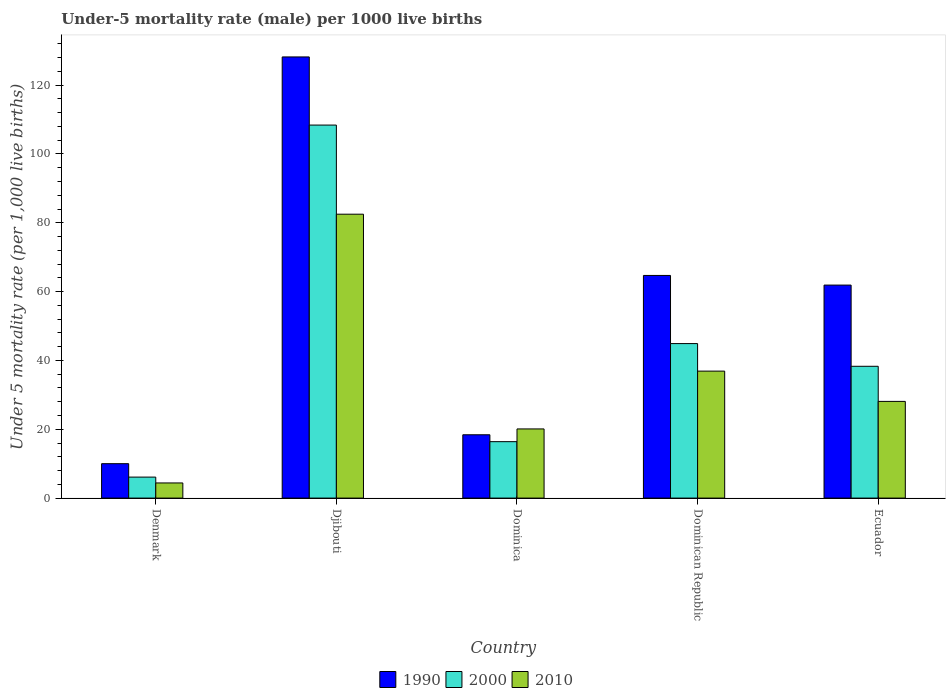How many groups of bars are there?
Ensure brevity in your answer.  5. How many bars are there on the 1st tick from the left?
Give a very brief answer. 3. How many bars are there on the 2nd tick from the right?
Offer a terse response. 3. In how many cases, is the number of bars for a given country not equal to the number of legend labels?
Offer a very short reply. 0. Across all countries, what is the maximum under-five mortality rate in 1990?
Keep it short and to the point. 128.2. In which country was the under-five mortality rate in 2010 maximum?
Provide a succinct answer. Djibouti. In which country was the under-five mortality rate in 1990 minimum?
Your answer should be compact. Denmark. What is the total under-five mortality rate in 2000 in the graph?
Provide a succinct answer. 214.1. What is the difference between the under-five mortality rate in 2010 in Denmark and that in Ecuador?
Keep it short and to the point. -23.7. What is the difference between the under-five mortality rate in 1990 in Dominican Republic and the under-five mortality rate in 2010 in Denmark?
Give a very brief answer. 60.3. What is the average under-five mortality rate in 2000 per country?
Your response must be concise. 42.82. What is the difference between the under-five mortality rate of/in 2000 and under-five mortality rate of/in 1990 in Dominican Republic?
Give a very brief answer. -19.8. In how many countries, is the under-five mortality rate in 2010 greater than 108?
Your answer should be compact. 0. What is the ratio of the under-five mortality rate in 1990 in Dominican Republic to that in Ecuador?
Ensure brevity in your answer.  1.05. Is the under-five mortality rate in 2000 in Denmark less than that in Dominica?
Your response must be concise. Yes. What is the difference between the highest and the second highest under-five mortality rate in 2010?
Provide a succinct answer. 45.6. What is the difference between the highest and the lowest under-five mortality rate in 2000?
Your answer should be very brief. 102.3. What does the 1st bar from the right in Dominican Republic represents?
Your response must be concise. 2010. Is it the case that in every country, the sum of the under-five mortality rate in 1990 and under-five mortality rate in 2010 is greater than the under-five mortality rate in 2000?
Offer a terse response. Yes. How many bars are there?
Your answer should be compact. 15. Are all the bars in the graph horizontal?
Provide a short and direct response. No. Are the values on the major ticks of Y-axis written in scientific E-notation?
Your response must be concise. No. Does the graph contain any zero values?
Provide a short and direct response. No. Where does the legend appear in the graph?
Your answer should be very brief. Bottom center. How many legend labels are there?
Your answer should be very brief. 3. How are the legend labels stacked?
Your answer should be compact. Horizontal. What is the title of the graph?
Ensure brevity in your answer.  Under-5 mortality rate (male) per 1000 live births. What is the label or title of the Y-axis?
Your answer should be compact. Under 5 mortality rate (per 1,0 live births). What is the Under 5 mortality rate (per 1,000 live births) in 1990 in Denmark?
Keep it short and to the point. 10. What is the Under 5 mortality rate (per 1,000 live births) of 1990 in Djibouti?
Give a very brief answer. 128.2. What is the Under 5 mortality rate (per 1,000 live births) in 2000 in Djibouti?
Your response must be concise. 108.4. What is the Under 5 mortality rate (per 1,000 live births) of 2010 in Djibouti?
Give a very brief answer. 82.5. What is the Under 5 mortality rate (per 1,000 live births) of 2010 in Dominica?
Ensure brevity in your answer.  20.1. What is the Under 5 mortality rate (per 1,000 live births) in 1990 in Dominican Republic?
Offer a terse response. 64.7. What is the Under 5 mortality rate (per 1,000 live births) in 2000 in Dominican Republic?
Keep it short and to the point. 44.9. What is the Under 5 mortality rate (per 1,000 live births) in 2010 in Dominican Republic?
Your answer should be compact. 36.9. What is the Under 5 mortality rate (per 1,000 live births) in 1990 in Ecuador?
Provide a short and direct response. 61.9. What is the Under 5 mortality rate (per 1,000 live births) in 2000 in Ecuador?
Keep it short and to the point. 38.3. What is the Under 5 mortality rate (per 1,000 live births) in 2010 in Ecuador?
Offer a terse response. 28.1. Across all countries, what is the maximum Under 5 mortality rate (per 1,000 live births) in 1990?
Provide a succinct answer. 128.2. Across all countries, what is the maximum Under 5 mortality rate (per 1,000 live births) in 2000?
Your response must be concise. 108.4. Across all countries, what is the maximum Under 5 mortality rate (per 1,000 live births) in 2010?
Offer a terse response. 82.5. Across all countries, what is the minimum Under 5 mortality rate (per 1,000 live births) in 2000?
Your answer should be compact. 6.1. What is the total Under 5 mortality rate (per 1,000 live births) in 1990 in the graph?
Offer a very short reply. 283.2. What is the total Under 5 mortality rate (per 1,000 live births) of 2000 in the graph?
Your answer should be very brief. 214.1. What is the total Under 5 mortality rate (per 1,000 live births) in 2010 in the graph?
Give a very brief answer. 172. What is the difference between the Under 5 mortality rate (per 1,000 live births) of 1990 in Denmark and that in Djibouti?
Offer a terse response. -118.2. What is the difference between the Under 5 mortality rate (per 1,000 live births) of 2000 in Denmark and that in Djibouti?
Provide a succinct answer. -102.3. What is the difference between the Under 5 mortality rate (per 1,000 live births) in 2010 in Denmark and that in Djibouti?
Offer a terse response. -78.1. What is the difference between the Under 5 mortality rate (per 1,000 live births) of 2010 in Denmark and that in Dominica?
Make the answer very short. -15.7. What is the difference between the Under 5 mortality rate (per 1,000 live births) of 1990 in Denmark and that in Dominican Republic?
Provide a succinct answer. -54.7. What is the difference between the Under 5 mortality rate (per 1,000 live births) in 2000 in Denmark and that in Dominican Republic?
Ensure brevity in your answer.  -38.8. What is the difference between the Under 5 mortality rate (per 1,000 live births) in 2010 in Denmark and that in Dominican Republic?
Ensure brevity in your answer.  -32.5. What is the difference between the Under 5 mortality rate (per 1,000 live births) in 1990 in Denmark and that in Ecuador?
Your response must be concise. -51.9. What is the difference between the Under 5 mortality rate (per 1,000 live births) in 2000 in Denmark and that in Ecuador?
Provide a short and direct response. -32.2. What is the difference between the Under 5 mortality rate (per 1,000 live births) in 2010 in Denmark and that in Ecuador?
Your answer should be very brief. -23.7. What is the difference between the Under 5 mortality rate (per 1,000 live births) of 1990 in Djibouti and that in Dominica?
Provide a succinct answer. 109.8. What is the difference between the Under 5 mortality rate (per 1,000 live births) of 2000 in Djibouti and that in Dominica?
Make the answer very short. 92. What is the difference between the Under 5 mortality rate (per 1,000 live births) of 2010 in Djibouti and that in Dominica?
Give a very brief answer. 62.4. What is the difference between the Under 5 mortality rate (per 1,000 live births) in 1990 in Djibouti and that in Dominican Republic?
Offer a terse response. 63.5. What is the difference between the Under 5 mortality rate (per 1,000 live births) of 2000 in Djibouti and that in Dominican Republic?
Keep it short and to the point. 63.5. What is the difference between the Under 5 mortality rate (per 1,000 live births) of 2010 in Djibouti and that in Dominican Republic?
Keep it short and to the point. 45.6. What is the difference between the Under 5 mortality rate (per 1,000 live births) of 1990 in Djibouti and that in Ecuador?
Your response must be concise. 66.3. What is the difference between the Under 5 mortality rate (per 1,000 live births) of 2000 in Djibouti and that in Ecuador?
Offer a terse response. 70.1. What is the difference between the Under 5 mortality rate (per 1,000 live births) in 2010 in Djibouti and that in Ecuador?
Keep it short and to the point. 54.4. What is the difference between the Under 5 mortality rate (per 1,000 live births) of 1990 in Dominica and that in Dominican Republic?
Your response must be concise. -46.3. What is the difference between the Under 5 mortality rate (per 1,000 live births) of 2000 in Dominica and that in Dominican Republic?
Give a very brief answer. -28.5. What is the difference between the Under 5 mortality rate (per 1,000 live births) in 2010 in Dominica and that in Dominican Republic?
Your answer should be very brief. -16.8. What is the difference between the Under 5 mortality rate (per 1,000 live births) in 1990 in Dominica and that in Ecuador?
Give a very brief answer. -43.5. What is the difference between the Under 5 mortality rate (per 1,000 live births) in 2000 in Dominica and that in Ecuador?
Provide a short and direct response. -21.9. What is the difference between the Under 5 mortality rate (per 1,000 live births) in 1990 in Denmark and the Under 5 mortality rate (per 1,000 live births) in 2000 in Djibouti?
Your answer should be compact. -98.4. What is the difference between the Under 5 mortality rate (per 1,000 live births) of 1990 in Denmark and the Under 5 mortality rate (per 1,000 live births) of 2010 in Djibouti?
Provide a succinct answer. -72.5. What is the difference between the Under 5 mortality rate (per 1,000 live births) of 2000 in Denmark and the Under 5 mortality rate (per 1,000 live births) of 2010 in Djibouti?
Provide a short and direct response. -76.4. What is the difference between the Under 5 mortality rate (per 1,000 live births) in 1990 in Denmark and the Under 5 mortality rate (per 1,000 live births) in 2000 in Dominica?
Your response must be concise. -6.4. What is the difference between the Under 5 mortality rate (per 1,000 live births) of 2000 in Denmark and the Under 5 mortality rate (per 1,000 live births) of 2010 in Dominica?
Your answer should be compact. -14. What is the difference between the Under 5 mortality rate (per 1,000 live births) in 1990 in Denmark and the Under 5 mortality rate (per 1,000 live births) in 2000 in Dominican Republic?
Offer a very short reply. -34.9. What is the difference between the Under 5 mortality rate (per 1,000 live births) in 1990 in Denmark and the Under 5 mortality rate (per 1,000 live births) in 2010 in Dominican Republic?
Your answer should be very brief. -26.9. What is the difference between the Under 5 mortality rate (per 1,000 live births) of 2000 in Denmark and the Under 5 mortality rate (per 1,000 live births) of 2010 in Dominican Republic?
Provide a succinct answer. -30.8. What is the difference between the Under 5 mortality rate (per 1,000 live births) in 1990 in Denmark and the Under 5 mortality rate (per 1,000 live births) in 2000 in Ecuador?
Keep it short and to the point. -28.3. What is the difference between the Under 5 mortality rate (per 1,000 live births) in 1990 in Denmark and the Under 5 mortality rate (per 1,000 live births) in 2010 in Ecuador?
Your answer should be very brief. -18.1. What is the difference between the Under 5 mortality rate (per 1,000 live births) of 1990 in Djibouti and the Under 5 mortality rate (per 1,000 live births) of 2000 in Dominica?
Provide a succinct answer. 111.8. What is the difference between the Under 5 mortality rate (per 1,000 live births) in 1990 in Djibouti and the Under 5 mortality rate (per 1,000 live births) in 2010 in Dominica?
Give a very brief answer. 108.1. What is the difference between the Under 5 mortality rate (per 1,000 live births) in 2000 in Djibouti and the Under 5 mortality rate (per 1,000 live births) in 2010 in Dominica?
Your answer should be compact. 88.3. What is the difference between the Under 5 mortality rate (per 1,000 live births) of 1990 in Djibouti and the Under 5 mortality rate (per 1,000 live births) of 2000 in Dominican Republic?
Make the answer very short. 83.3. What is the difference between the Under 5 mortality rate (per 1,000 live births) of 1990 in Djibouti and the Under 5 mortality rate (per 1,000 live births) of 2010 in Dominican Republic?
Offer a very short reply. 91.3. What is the difference between the Under 5 mortality rate (per 1,000 live births) in 2000 in Djibouti and the Under 5 mortality rate (per 1,000 live births) in 2010 in Dominican Republic?
Make the answer very short. 71.5. What is the difference between the Under 5 mortality rate (per 1,000 live births) of 1990 in Djibouti and the Under 5 mortality rate (per 1,000 live births) of 2000 in Ecuador?
Make the answer very short. 89.9. What is the difference between the Under 5 mortality rate (per 1,000 live births) of 1990 in Djibouti and the Under 5 mortality rate (per 1,000 live births) of 2010 in Ecuador?
Provide a short and direct response. 100.1. What is the difference between the Under 5 mortality rate (per 1,000 live births) of 2000 in Djibouti and the Under 5 mortality rate (per 1,000 live births) of 2010 in Ecuador?
Offer a terse response. 80.3. What is the difference between the Under 5 mortality rate (per 1,000 live births) in 1990 in Dominica and the Under 5 mortality rate (per 1,000 live births) in 2000 in Dominican Republic?
Provide a short and direct response. -26.5. What is the difference between the Under 5 mortality rate (per 1,000 live births) of 1990 in Dominica and the Under 5 mortality rate (per 1,000 live births) of 2010 in Dominican Republic?
Make the answer very short. -18.5. What is the difference between the Under 5 mortality rate (per 1,000 live births) in 2000 in Dominica and the Under 5 mortality rate (per 1,000 live births) in 2010 in Dominican Republic?
Offer a terse response. -20.5. What is the difference between the Under 5 mortality rate (per 1,000 live births) in 1990 in Dominica and the Under 5 mortality rate (per 1,000 live births) in 2000 in Ecuador?
Give a very brief answer. -19.9. What is the difference between the Under 5 mortality rate (per 1,000 live births) in 1990 in Dominica and the Under 5 mortality rate (per 1,000 live births) in 2010 in Ecuador?
Your answer should be compact. -9.7. What is the difference between the Under 5 mortality rate (per 1,000 live births) in 2000 in Dominica and the Under 5 mortality rate (per 1,000 live births) in 2010 in Ecuador?
Provide a succinct answer. -11.7. What is the difference between the Under 5 mortality rate (per 1,000 live births) in 1990 in Dominican Republic and the Under 5 mortality rate (per 1,000 live births) in 2000 in Ecuador?
Provide a short and direct response. 26.4. What is the difference between the Under 5 mortality rate (per 1,000 live births) in 1990 in Dominican Republic and the Under 5 mortality rate (per 1,000 live births) in 2010 in Ecuador?
Your response must be concise. 36.6. What is the average Under 5 mortality rate (per 1,000 live births) of 1990 per country?
Provide a short and direct response. 56.64. What is the average Under 5 mortality rate (per 1,000 live births) of 2000 per country?
Offer a terse response. 42.82. What is the average Under 5 mortality rate (per 1,000 live births) of 2010 per country?
Offer a very short reply. 34.4. What is the difference between the Under 5 mortality rate (per 1,000 live births) in 2000 and Under 5 mortality rate (per 1,000 live births) in 2010 in Denmark?
Provide a succinct answer. 1.7. What is the difference between the Under 5 mortality rate (per 1,000 live births) in 1990 and Under 5 mortality rate (per 1,000 live births) in 2000 in Djibouti?
Ensure brevity in your answer.  19.8. What is the difference between the Under 5 mortality rate (per 1,000 live births) of 1990 and Under 5 mortality rate (per 1,000 live births) of 2010 in Djibouti?
Keep it short and to the point. 45.7. What is the difference between the Under 5 mortality rate (per 1,000 live births) in 2000 and Under 5 mortality rate (per 1,000 live births) in 2010 in Djibouti?
Offer a terse response. 25.9. What is the difference between the Under 5 mortality rate (per 1,000 live births) of 1990 and Under 5 mortality rate (per 1,000 live births) of 2000 in Dominica?
Offer a terse response. 2. What is the difference between the Under 5 mortality rate (per 1,000 live births) in 1990 and Under 5 mortality rate (per 1,000 live births) in 2010 in Dominica?
Your response must be concise. -1.7. What is the difference between the Under 5 mortality rate (per 1,000 live births) of 1990 and Under 5 mortality rate (per 1,000 live births) of 2000 in Dominican Republic?
Keep it short and to the point. 19.8. What is the difference between the Under 5 mortality rate (per 1,000 live births) of 1990 and Under 5 mortality rate (per 1,000 live births) of 2010 in Dominican Republic?
Provide a succinct answer. 27.8. What is the difference between the Under 5 mortality rate (per 1,000 live births) of 1990 and Under 5 mortality rate (per 1,000 live births) of 2000 in Ecuador?
Make the answer very short. 23.6. What is the difference between the Under 5 mortality rate (per 1,000 live births) of 1990 and Under 5 mortality rate (per 1,000 live births) of 2010 in Ecuador?
Provide a short and direct response. 33.8. What is the ratio of the Under 5 mortality rate (per 1,000 live births) of 1990 in Denmark to that in Djibouti?
Offer a very short reply. 0.08. What is the ratio of the Under 5 mortality rate (per 1,000 live births) of 2000 in Denmark to that in Djibouti?
Offer a very short reply. 0.06. What is the ratio of the Under 5 mortality rate (per 1,000 live births) in 2010 in Denmark to that in Djibouti?
Provide a short and direct response. 0.05. What is the ratio of the Under 5 mortality rate (per 1,000 live births) in 1990 in Denmark to that in Dominica?
Offer a terse response. 0.54. What is the ratio of the Under 5 mortality rate (per 1,000 live births) in 2000 in Denmark to that in Dominica?
Provide a succinct answer. 0.37. What is the ratio of the Under 5 mortality rate (per 1,000 live births) of 2010 in Denmark to that in Dominica?
Provide a succinct answer. 0.22. What is the ratio of the Under 5 mortality rate (per 1,000 live births) in 1990 in Denmark to that in Dominican Republic?
Provide a short and direct response. 0.15. What is the ratio of the Under 5 mortality rate (per 1,000 live births) in 2000 in Denmark to that in Dominican Republic?
Offer a terse response. 0.14. What is the ratio of the Under 5 mortality rate (per 1,000 live births) in 2010 in Denmark to that in Dominican Republic?
Ensure brevity in your answer.  0.12. What is the ratio of the Under 5 mortality rate (per 1,000 live births) in 1990 in Denmark to that in Ecuador?
Give a very brief answer. 0.16. What is the ratio of the Under 5 mortality rate (per 1,000 live births) of 2000 in Denmark to that in Ecuador?
Keep it short and to the point. 0.16. What is the ratio of the Under 5 mortality rate (per 1,000 live births) of 2010 in Denmark to that in Ecuador?
Keep it short and to the point. 0.16. What is the ratio of the Under 5 mortality rate (per 1,000 live births) of 1990 in Djibouti to that in Dominica?
Keep it short and to the point. 6.97. What is the ratio of the Under 5 mortality rate (per 1,000 live births) of 2000 in Djibouti to that in Dominica?
Your answer should be very brief. 6.61. What is the ratio of the Under 5 mortality rate (per 1,000 live births) in 2010 in Djibouti to that in Dominica?
Your answer should be compact. 4.1. What is the ratio of the Under 5 mortality rate (per 1,000 live births) in 1990 in Djibouti to that in Dominican Republic?
Provide a succinct answer. 1.98. What is the ratio of the Under 5 mortality rate (per 1,000 live births) of 2000 in Djibouti to that in Dominican Republic?
Make the answer very short. 2.41. What is the ratio of the Under 5 mortality rate (per 1,000 live births) of 2010 in Djibouti to that in Dominican Republic?
Ensure brevity in your answer.  2.24. What is the ratio of the Under 5 mortality rate (per 1,000 live births) of 1990 in Djibouti to that in Ecuador?
Give a very brief answer. 2.07. What is the ratio of the Under 5 mortality rate (per 1,000 live births) of 2000 in Djibouti to that in Ecuador?
Your answer should be very brief. 2.83. What is the ratio of the Under 5 mortality rate (per 1,000 live births) of 2010 in Djibouti to that in Ecuador?
Give a very brief answer. 2.94. What is the ratio of the Under 5 mortality rate (per 1,000 live births) of 1990 in Dominica to that in Dominican Republic?
Offer a terse response. 0.28. What is the ratio of the Under 5 mortality rate (per 1,000 live births) of 2000 in Dominica to that in Dominican Republic?
Offer a terse response. 0.37. What is the ratio of the Under 5 mortality rate (per 1,000 live births) in 2010 in Dominica to that in Dominican Republic?
Keep it short and to the point. 0.54. What is the ratio of the Under 5 mortality rate (per 1,000 live births) of 1990 in Dominica to that in Ecuador?
Make the answer very short. 0.3. What is the ratio of the Under 5 mortality rate (per 1,000 live births) of 2000 in Dominica to that in Ecuador?
Your answer should be very brief. 0.43. What is the ratio of the Under 5 mortality rate (per 1,000 live births) in 2010 in Dominica to that in Ecuador?
Make the answer very short. 0.72. What is the ratio of the Under 5 mortality rate (per 1,000 live births) in 1990 in Dominican Republic to that in Ecuador?
Offer a terse response. 1.05. What is the ratio of the Under 5 mortality rate (per 1,000 live births) of 2000 in Dominican Republic to that in Ecuador?
Your answer should be compact. 1.17. What is the ratio of the Under 5 mortality rate (per 1,000 live births) of 2010 in Dominican Republic to that in Ecuador?
Offer a terse response. 1.31. What is the difference between the highest and the second highest Under 5 mortality rate (per 1,000 live births) in 1990?
Ensure brevity in your answer.  63.5. What is the difference between the highest and the second highest Under 5 mortality rate (per 1,000 live births) of 2000?
Offer a terse response. 63.5. What is the difference between the highest and the second highest Under 5 mortality rate (per 1,000 live births) in 2010?
Ensure brevity in your answer.  45.6. What is the difference between the highest and the lowest Under 5 mortality rate (per 1,000 live births) of 1990?
Give a very brief answer. 118.2. What is the difference between the highest and the lowest Under 5 mortality rate (per 1,000 live births) of 2000?
Your answer should be very brief. 102.3. What is the difference between the highest and the lowest Under 5 mortality rate (per 1,000 live births) of 2010?
Offer a terse response. 78.1. 